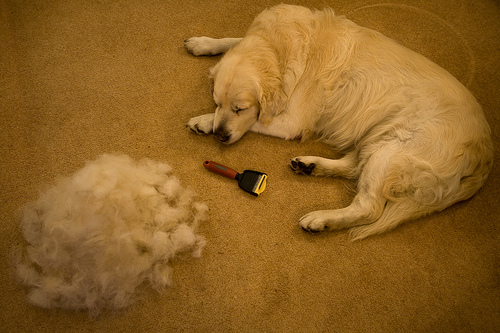<image>
Is there a dog on the carpet? Yes. Looking at the image, I can see the dog is positioned on top of the carpet, with the carpet providing support. 